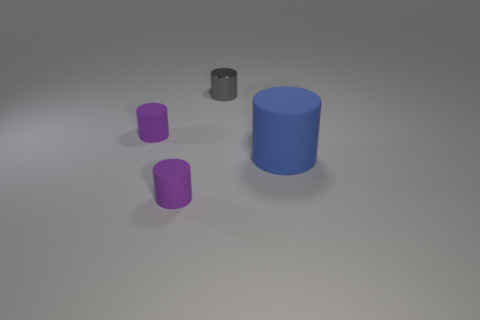Add 1 purple cylinders. How many objects exist? 5 Subtract all tiny gray metallic cylinders. How many cylinders are left? 3 Subtract all gray spheres. How many purple cylinders are left? 2 Subtract 2 cylinders. How many cylinders are left? 2 Subtract all blue cylinders. How many cylinders are left? 3 Add 3 gray objects. How many gray objects exist? 4 Subtract 0 brown cubes. How many objects are left? 4 Subtract all blue cylinders. Subtract all cyan spheres. How many cylinders are left? 3 Subtract all tiny shiny objects. Subtract all metallic things. How many objects are left? 2 Add 4 tiny metallic cylinders. How many tiny metallic cylinders are left? 5 